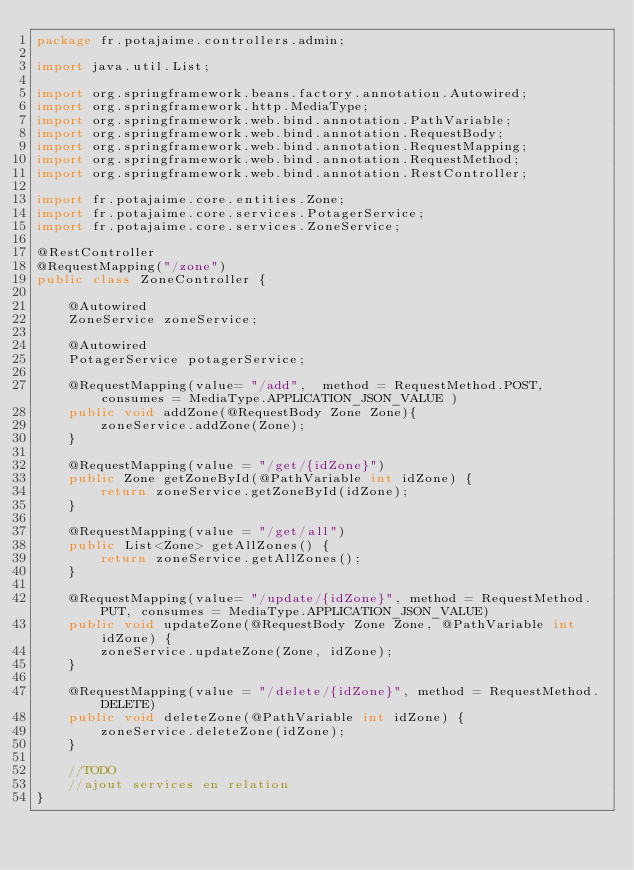<code> <loc_0><loc_0><loc_500><loc_500><_Java_>package fr.potajaime.controllers.admin;

import java.util.List;

import org.springframework.beans.factory.annotation.Autowired;
import org.springframework.http.MediaType;
import org.springframework.web.bind.annotation.PathVariable;
import org.springframework.web.bind.annotation.RequestBody;
import org.springframework.web.bind.annotation.RequestMapping;
import org.springframework.web.bind.annotation.RequestMethod;
import org.springframework.web.bind.annotation.RestController;

import fr.potajaime.core.entities.Zone;
import fr.potajaime.core.services.PotagerService;
import fr.potajaime.core.services.ZoneService;

@RestController
@RequestMapping("/zone")
public class ZoneController {

	@Autowired
	ZoneService zoneService;
	
	@Autowired
	PotagerService potagerService;
	
	@RequestMapping(value= "/add",  method = RequestMethod.POST, consumes = MediaType.APPLICATION_JSON_VALUE )
	public void addZone(@RequestBody Zone Zone){
		zoneService.addZone(Zone);
	}
	
	@RequestMapping(value = "/get/{idZone}")
    public Zone getZoneById(@PathVariable int idZone) {
        return zoneService.getZoneById(idZone);
    }
	
	@RequestMapping(value = "/get/all") 
	public List<Zone> getAllZones() {
		return zoneService.getAllZones();
	}

    @RequestMapping(value= "/update/{idZone}", method = RequestMethod.PUT, consumes = MediaType.APPLICATION_JSON_VALUE)
    public void updateZone(@RequestBody Zone Zone, @PathVariable int idZone) {
    	zoneService.updateZone(Zone, idZone);
    }

    @RequestMapping(value = "/delete/{idZone}", method = RequestMethod.DELETE) 
    public void deleteZone(@PathVariable int idZone) {
    	zoneService.deleteZone(idZone); 
    }
    
    //TODO
    //ajout services en relation
}
</code> 